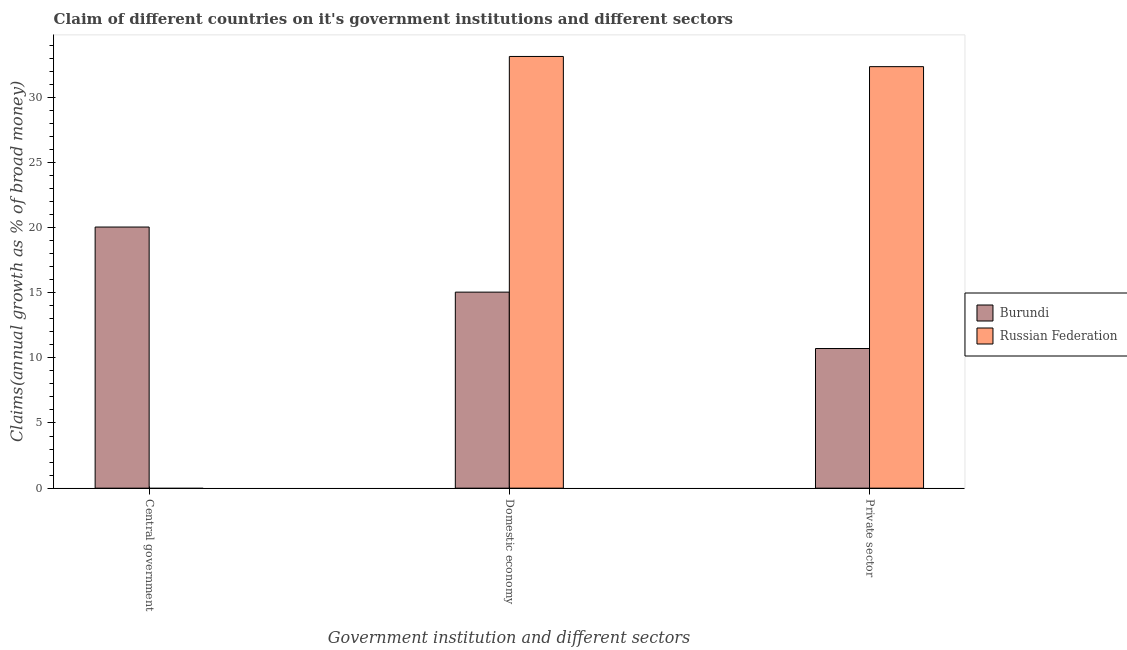Are the number of bars on each tick of the X-axis equal?
Make the answer very short. No. How many bars are there on the 1st tick from the right?
Make the answer very short. 2. What is the label of the 2nd group of bars from the left?
Keep it short and to the point. Domestic economy. What is the percentage of claim on the private sector in Russian Federation?
Offer a very short reply. 32.34. Across all countries, what is the maximum percentage of claim on the central government?
Ensure brevity in your answer.  20.04. Across all countries, what is the minimum percentage of claim on the domestic economy?
Your response must be concise. 15.04. In which country was the percentage of claim on the private sector maximum?
Offer a very short reply. Russian Federation. What is the total percentage of claim on the private sector in the graph?
Provide a short and direct response. 43.06. What is the difference between the percentage of claim on the domestic economy in Burundi and that in Russian Federation?
Provide a short and direct response. -18.08. What is the difference between the percentage of claim on the private sector in Russian Federation and the percentage of claim on the central government in Burundi?
Your response must be concise. 12.31. What is the average percentage of claim on the private sector per country?
Ensure brevity in your answer.  21.53. What is the difference between the percentage of claim on the domestic economy and percentage of claim on the private sector in Burundi?
Your response must be concise. 4.33. In how many countries, is the percentage of claim on the private sector greater than 31 %?
Your answer should be very brief. 1. What is the ratio of the percentage of claim on the private sector in Burundi to that in Russian Federation?
Provide a succinct answer. 0.33. Is the percentage of claim on the domestic economy in Russian Federation less than that in Burundi?
Offer a very short reply. No. Is the difference between the percentage of claim on the private sector in Burundi and Russian Federation greater than the difference between the percentage of claim on the domestic economy in Burundi and Russian Federation?
Keep it short and to the point. No. What is the difference between the highest and the second highest percentage of claim on the domestic economy?
Offer a very short reply. 18.08. What is the difference between the highest and the lowest percentage of claim on the private sector?
Your response must be concise. 21.63. Is the sum of the percentage of claim on the domestic economy in Burundi and Russian Federation greater than the maximum percentage of claim on the central government across all countries?
Give a very brief answer. Yes. Is it the case that in every country, the sum of the percentage of claim on the central government and percentage of claim on the domestic economy is greater than the percentage of claim on the private sector?
Keep it short and to the point. Yes. What is the difference between two consecutive major ticks on the Y-axis?
Provide a short and direct response. 5. Does the graph contain any zero values?
Offer a very short reply. Yes. Where does the legend appear in the graph?
Ensure brevity in your answer.  Center right. What is the title of the graph?
Offer a terse response. Claim of different countries on it's government institutions and different sectors. Does "Japan" appear as one of the legend labels in the graph?
Give a very brief answer. No. What is the label or title of the X-axis?
Your answer should be very brief. Government institution and different sectors. What is the label or title of the Y-axis?
Your answer should be very brief. Claims(annual growth as % of broad money). What is the Claims(annual growth as % of broad money) in Burundi in Central government?
Your answer should be very brief. 20.04. What is the Claims(annual growth as % of broad money) of Burundi in Domestic economy?
Your answer should be very brief. 15.04. What is the Claims(annual growth as % of broad money) in Russian Federation in Domestic economy?
Your answer should be very brief. 33.13. What is the Claims(annual growth as % of broad money) of Burundi in Private sector?
Ensure brevity in your answer.  10.72. What is the Claims(annual growth as % of broad money) of Russian Federation in Private sector?
Offer a terse response. 32.34. Across all Government institution and different sectors, what is the maximum Claims(annual growth as % of broad money) in Burundi?
Your answer should be compact. 20.04. Across all Government institution and different sectors, what is the maximum Claims(annual growth as % of broad money) in Russian Federation?
Ensure brevity in your answer.  33.13. Across all Government institution and different sectors, what is the minimum Claims(annual growth as % of broad money) in Burundi?
Make the answer very short. 10.72. Across all Government institution and different sectors, what is the minimum Claims(annual growth as % of broad money) of Russian Federation?
Provide a succinct answer. 0. What is the total Claims(annual growth as % of broad money) in Burundi in the graph?
Your answer should be very brief. 45.79. What is the total Claims(annual growth as % of broad money) of Russian Federation in the graph?
Keep it short and to the point. 65.47. What is the difference between the Claims(annual growth as % of broad money) of Burundi in Central government and that in Domestic economy?
Offer a very short reply. 4.99. What is the difference between the Claims(annual growth as % of broad money) in Burundi in Central government and that in Private sector?
Ensure brevity in your answer.  9.32. What is the difference between the Claims(annual growth as % of broad money) of Burundi in Domestic economy and that in Private sector?
Provide a succinct answer. 4.33. What is the difference between the Claims(annual growth as % of broad money) in Russian Federation in Domestic economy and that in Private sector?
Provide a short and direct response. 0.78. What is the difference between the Claims(annual growth as % of broad money) of Burundi in Central government and the Claims(annual growth as % of broad money) of Russian Federation in Domestic economy?
Ensure brevity in your answer.  -13.09. What is the difference between the Claims(annual growth as % of broad money) of Burundi in Central government and the Claims(annual growth as % of broad money) of Russian Federation in Private sector?
Give a very brief answer. -12.31. What is the difference between the Claims(annual growth as % of broad money) of Burundi in Domestic economy and the Claims(annual growth as % of broad money) of Russian Federation in Private sector?
Offer a very short reply. -17.3. What is the average Claims(annual growth as % of broad money) in Burundi per Government institution and different sectors?
Provide a short and direct response. 15.26. What is the average Claims(annual growth as % of broad money) of Russian Federation per Government institution and different sectors?
Ensure brevity in your answer.  21.82. What is the difference between the Claims(annual growth as % of broad money) in Burundi and Claims(annual growth as % of broad money) in Russian Federation in Domestic economy?
Your response must be concise. -18.08. What is the difference between the Claims(annual growth as % of broad money) of Burundi and Claims(annual growth as % of broad money) of Russian Federation in Private sector?
Ensure brevity in your answer.  -21.63. What is the ratio of the Claims(annual growth as % of broad money) in Burundi in Central government to that in Domestic economy?
Offer a very short reply. 1.33. What is the ratio of the Claims(annual growth as % of broad money) in Burundi in Central government to that in Private sector?
Provide a succinct answer. 1.87. What is the ratio of the Claims(annual growth as % of broad money) of Burundi in Domestic economy to that in Private sector?
Offer a terse response. 1.4. What is the ratio of the Claims(annual growth as % of broad money) of Russian Federation in Domestic economy to that in Private sector?
Offer a very short reply. 1.02. What is the difference between the highest and the second highest Claims(annual growth as % of broad money) in Burundi?
Give a very brief answer. 4.99. What is the difference between the highest and the lowest Claims(annual growth as % of broad money) of Burundi?
Provide a short and direct response. 9.32. What is the difference between the highest and the lowest Claims(annual growth as % of broad money) in Russian Federation?
Provide a short and direct response. 33.13. 